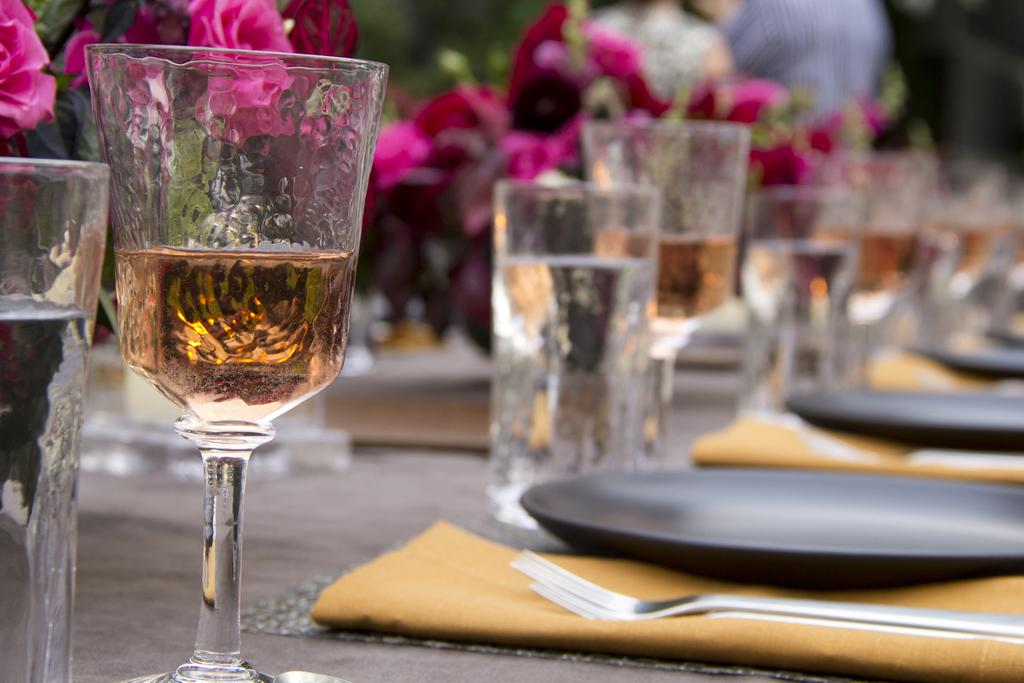What piece of furniture is present in the image? There is a table in the image. What items can be seen on the table? There are glasses, plates, a flowerpot, and spoons on the table. How many items are on the table? There are at least four items on the table: glasses, plates, a flowerpot, and spoons. What type of wax is being used to fold the table in the image? There is no wax or folding of the table in the image; it is a stationary piece of furniture with items placed on it. 